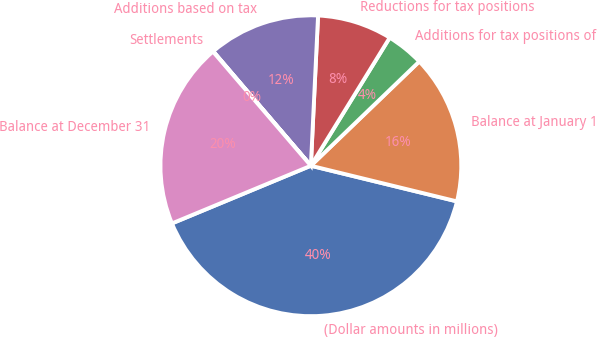Convert chart to OTSL. <chart><loc_0><loc_0><loc_500><loc_500><pie_chart><fcel>(Dollar amounts in millions)<fcel>Balance at January 1<fcel>Additions for tax positions of<fcel>Reductions for tax positions<fcel>Additions based on tax<fcel>Settlements<fcel>Balance at December 31<nl><fcel>39.93%<fcel>16.0%<fcel>4.03%<fcel>8.02%<fcel>12.01%<fcel>0.04%<fcel>19.98%<nl></chart> 